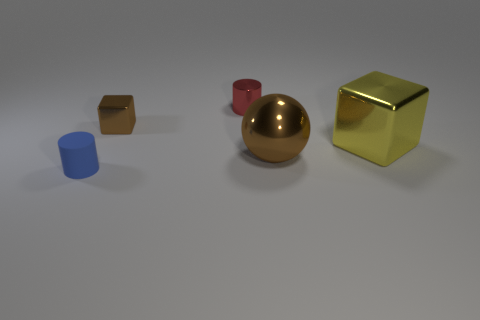There is a large object that is the same shape as the small brown metallic object; what color is it?
Give a very brief answer. Yellow. Are the large ball and the cylinder in front of the yellow thing made of the same material?
Provide a succinct answer. No. Is the number of red objects that are in front of the large yellow cube less than the number of yellow metallic things in front of the tiny red metallic object?
Keep it short and to the point. Yes. There is a tiny cylinder that is behind the small blue cylinder; what color is it?
Offer a terse response. Red. How many other things are there of the same color as the big shiny sphere?
Provide a short and direct response. 1. There is a metal block left of the metallic cylinder; is its size the same as the big metal cube?
Your answer should be compact. No. What number of small blue matte objects are right of the brown metallic sphere?
Make the answer very short. 0. Is there a metallic block that has the same size as the brown metal ball?
Your answer should be very brief. Yes. Is the color of the ball the same as the small metal block?
Offer a terse response. Yes. There is a big metallic block that is right of the cylinder behind the big cube; what color is it?
Ensure brevity in your answer.  Yellow. 